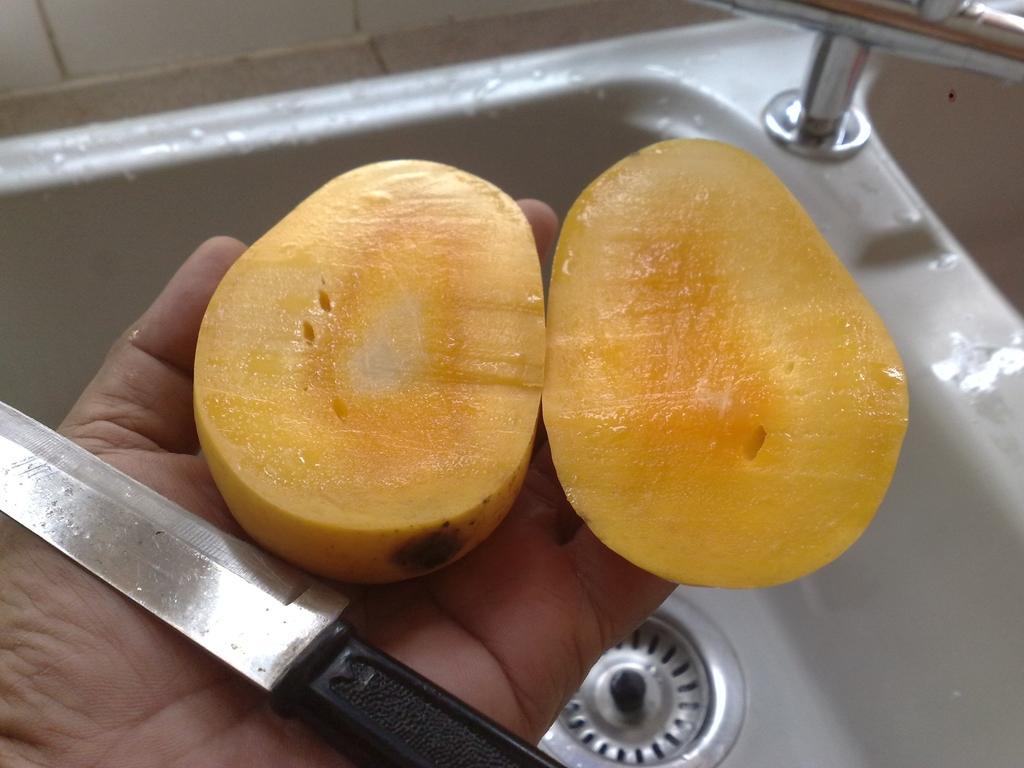How would you summarize this image in a sentence or two? In the image I can see a mango and a knife on a person hand. In the background I can see a sink, a tap and some other objects. 